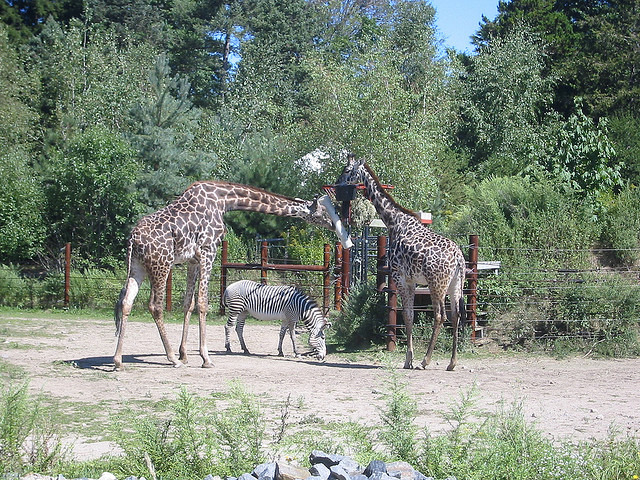How do giraffes and zebras interact with each other in the wild? In their natural savanna habitats, giraffes and zebras can often be found in proximity to each other. Giraffes, with their long necks, browse on high leaves and twigs, mostly eating from tall trees – acacias being a favorite. Zebras, on the other hand, graze on ground-level grasses. While they don't typically interact directly, they benefit from each other's presence. Zebras may take advantage of the giraffes' height, as giraffes can spot predators from a distance. In turn, the zebras' keen hearing and sense of smell help alert giraffes to possible dangers. Together, they form an informal mutualistic relationship, staying alert to the presence of predators. 